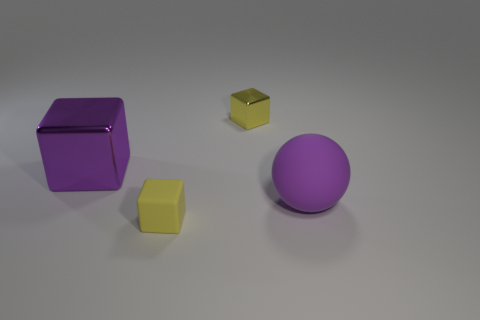Add 1 large green rubber spheres. How many objects exist? 5 Subtract all spheres. How many objects are left? 3 Subtract 0 cyan spheres. How many objects are left? 4 Subtract all big yellow metallic spheres. Subtract all purple rubber things. How many objects are left? 3 Add 3 purple things. How many purple things are left? 5 Add 4 small gray matte blocks. How many small gray matte blocks exist? 4 